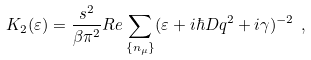Convert formula to latex. <formula><loc_0><loc_0><loc_500><loc_500>K _ { 2 } ( \varepsilon ) = \frac { s ^ { 2 } } { \beta \pi ^ { 2 } } R e \sum _ { \{ n _ { \mu } \} } ( \varepsilon + i \hbar { D } q ^ { 2 } + i \gamma ) ^ { - 2 } \ ,</formula> 